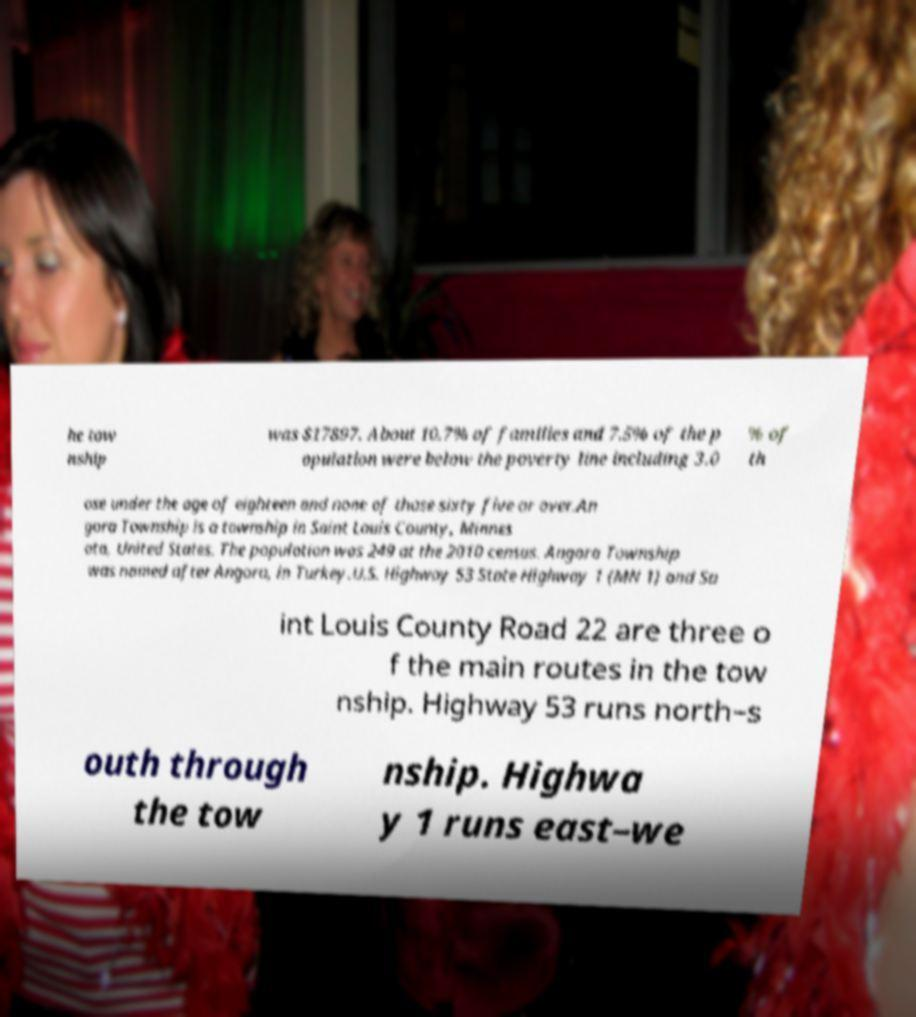What messages or text are displayed in this image? I need them in a readable, typed format. he tow nship was $17897. About 10.7% of families and 7.5% of the p opulation were below the poverty line including 3.0 % of th ose under the age of eighteen and none of those sixty five or over.An gora Township is a township in Saint Louis County, Minnes ota, United States. The population was 249 at the 2010 census. Angora Township was named after Angora, in Turkey.U.S. Highway 53 State Highway 1 (MN 1) and Sa int Louis County Road 22 are three o f the main routes in the tow nship. Highway 53 runs north–s outh through the tow nship. Highwa y 1 runs east–we 